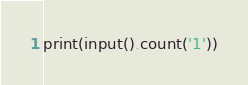<code> <loc_0><loc_0><loc_500><loc_500><_Python_>print(input().count('1'))
</code> 